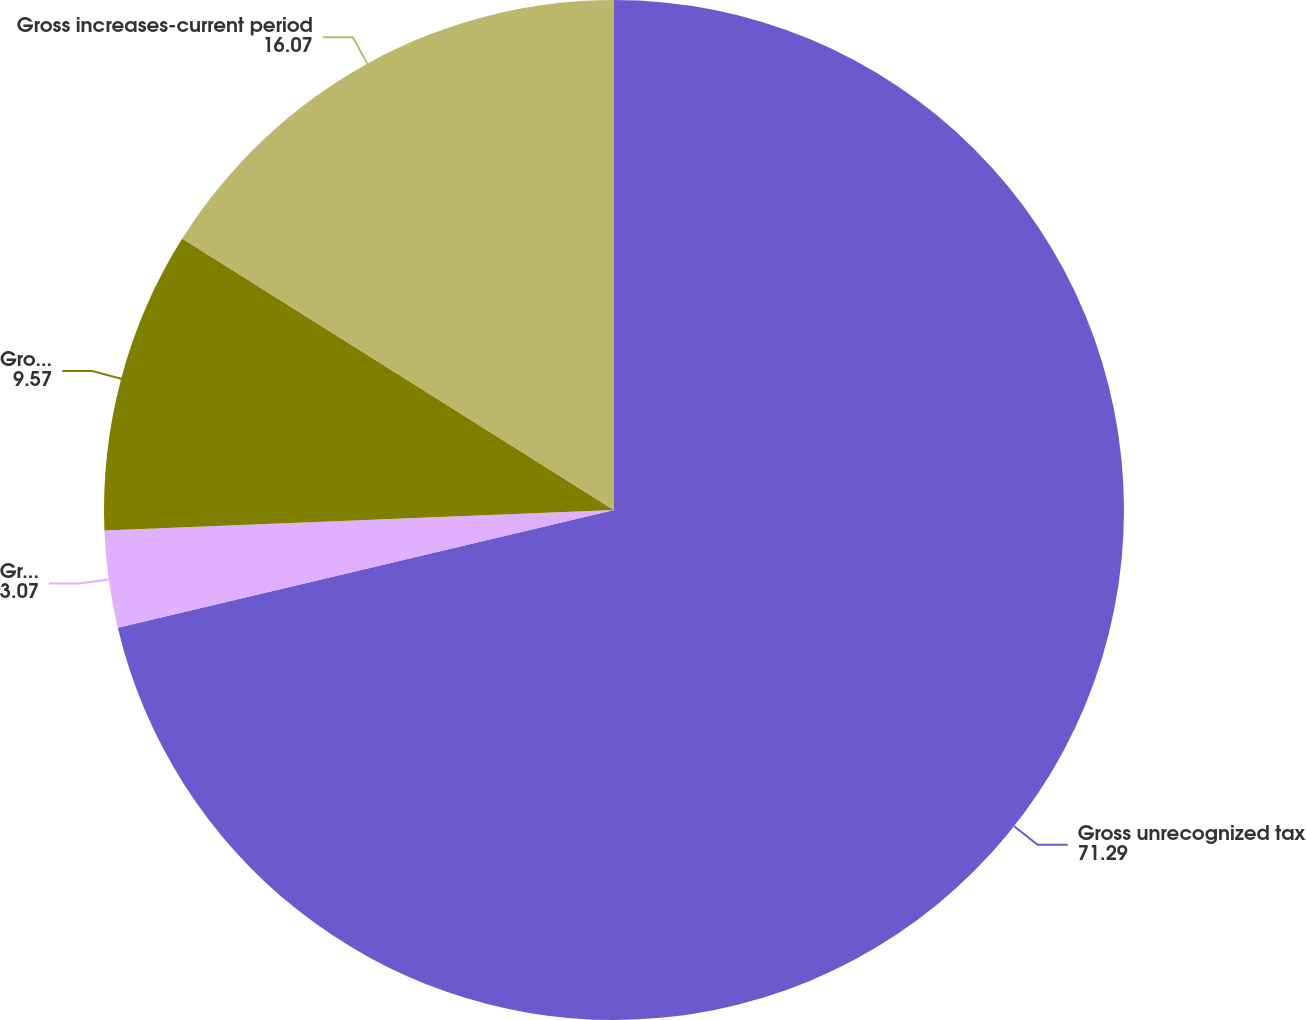<chart> <loc_0><loc_0><loc_500><loc_500><pie_chart><fcel>Gross unrecognized tax<fcel>Gross increases-prior period<fcel>Gross decreases-prior period<fcel>Gross increases-current period<nl><fcel>71.29%<fcel>3.07%<fcel>9.57%<fcel>16.07%<nl></chart> 